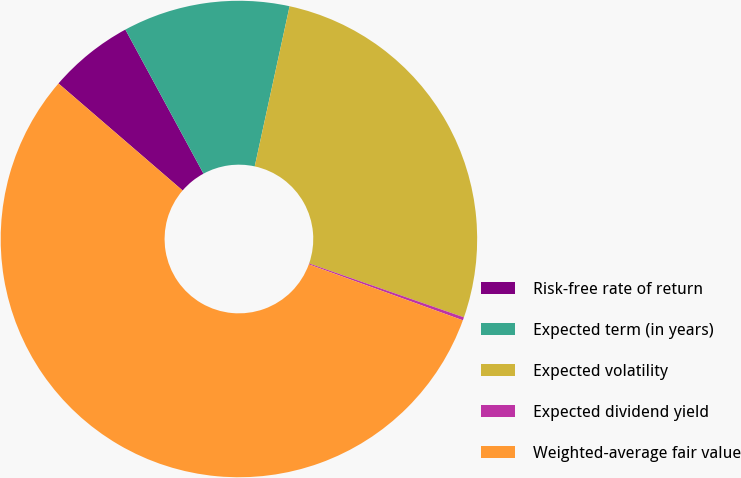<chart> <loc_0><loc_0><loc_500><loc_500><pie_chart><fcel>Risk-free rate of return<fcel>Expected term (in years)<fcel>Expected volatility<fcel>Expected dividend yield<fcel>Weighted-average fair value<nl><fcel>5.77%<fcel>11.32%<fcel>26.92%<fcel>0.21%<fcel>55.78%<nl></chart> 